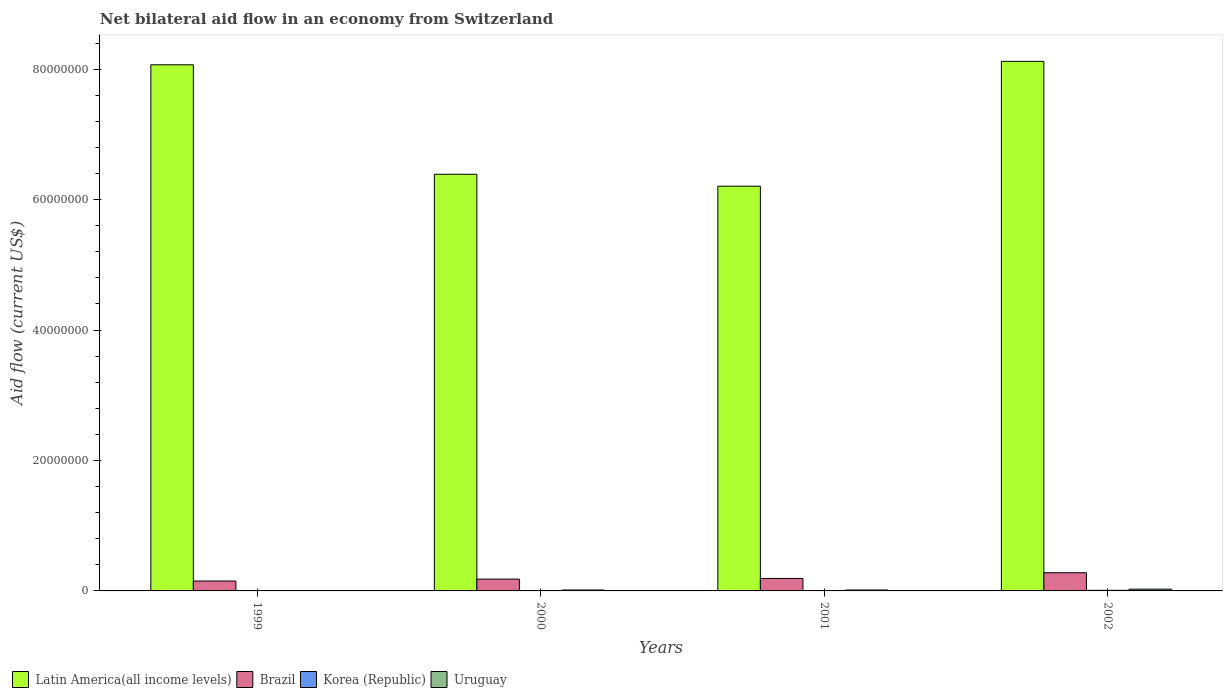How many groups of bars are there?
Make the answer very short. 4. Are the number of bars per tick equal to the number of legend labels?
Make the answer very short. Yes. How many bars are there on the 4th tick from the left?
Your answer should be very brief. 4. What is the label of the 2nd group of bars from the left?
Make the answer very short. 2000. In how many cases, is the number of bars for a given year not equal to the number of legend labels?
Your answer should be very brief. 0. What is the net bilateral aid flow in Latin America(all income levels) in 2000?
Make the answer very short. 6.39e+07. What is the total net bilateral aid flow in Uruguay in the graph?
Offer a terse response. 5.80e+05. What is the difference between the net bilateral aid flow in Korea (Republic) in 2000 and that in 2002?
Your response must be concise. -5.00e+04. What is the difference between the net bilateral aid flow in Latin America(all income levels) in 2002 and the net bilateral aid flow in Korea (Republic) in 1999?
Keep it short and to the point. 8.11e+07. What is the average net bilateral aid flow in Korea (Republic) per year?
Give a very brief answer. 6.00e+04. In the year 1999, what is the difference between the net bilateral aid flow in Korea (Republic) and net bilateral aid flow in Brazil?
Offer a very short reply. -1.47e+06. What is the ratio of the net bilateral aid flow in Latin America(all income levels) in 2000 to that in 2002?
Give a very brief answer. 0.79. What is the difference between the highest and the second highest net bilateral aid flow in Uruguay?
Provide a succinct answer. 1.30e+05. What is the difference between the highest and the lowest net bilateral aid flow in Latin America(all income levels)?
Your answer should be very brief. 1.91e+07. Is the sum of the net bilateral aid flow in Brazil in 2000 and 2002 greater than the maximum net bilateral aid flow in Latin America(all income levels) across all years?
Your answer should be compact. No. Is it the case that in every year, the sum of the net bilateral aid flow in Latin America(all income levels) and net bilateral aid flow in Brazil is greater than the sum of net bilateral aid flow in Uruguay and net bilateral aid flow in Korea (Republic)?
Give a very brief answer. Yes. What does the 1st bar from the left in 2001 represents?
Ensure brevity in your answer.  Latin America(all income levels). What does the 1st bar from the right in 2002 represents?
Your response must be concise. Uruguay. Are all the bars in the graph horizontal?
Offer a terse response. No. How are the legend labels stacked?
Ensure brevity in your answer.  Horizontal. What is the title of the graph?
Make the answer very short. Net bilateral aid flow in an economy from Switzerland. What is the label or title of the Y-axis?
Your response must be concise. Aid flow (current US$). What is the Aid flow (current US$) of Latin America(all income levels) in 1999?
Offer a very short reply. 8.07e+07. What is the Aid flow (current US$) of Brazil in 1999?
Your response must be concise. 1.52e+06. What is the Aid flow (current US$) of Uruguay in 1999?
Ensure brevity in your answer.  3.00e+04. What is the Aid flow (current US$) of Latin America(all income levels) in 2000?
Make the answer very short. 6.39e+07. What is the Aid flow (current US$) in Brazil in 2000?
Make the answer very short. 1.81e+06. What is the Aid flow (current US$) in Korea (Republic) in 2000?
Your answer should be very brief. 4.00e+04. What is the Aid flow (current US$) of Latin America(all income levels) in 2001?
Give a very brief answer. 6.20e+07. What is the Aid flow (current US$) in Brazil in 2001?
Offer a terse response. 1.91e+06. What is the Aid flow (current US$) of Latin America(all income levels) in 2002?
Make the answer very short. 8.12e+07. What is the Aid flow (current US$) in Brazil in 2002?
Your response must be concise. 2.79e+06. What is the Aid flow (current US$) in Uruguay in 2002?
Ensure brevity in your answer.  2.70e+05. Across all years, what is the maximum Aid flow (current US$) in Latin America(all income levels)?
Give a very brief answer. 8.12e+07. Across all years, what is the maximum Aid flow (current US$) in Brazil?
Your answer should be very brief. 2.79e+06. Across all years, what is the maximum Aid flow (current US$) of Korea (Republic)?
Your response must be concise. 9.00e+04. Across all years, what is the maximum Aid flow (current US$) in Uruguay?
Provide a short and direct response. 2.70e+05. Across all years, what is the minimum Aid flow (current US$) of Latin America(all income levels)?
Provide a succinct answer. 6.20e+07. Across all years, what is the minimum Aid flow (current US$) of Brazil?
Offer a terse response. 1.52e+06. Across all years, what is the minimum Aid flow (current US$) in Uruguay?
Your response must be concise. 3.00e+04. What is the total Aid flow (current US$) of Latin America(all income levels) in the graph?
Provide a short and direct response. 2.88e+08. What is the total Aid flow (current US$) in Brazil in the graph?
Your answer should be very brief. 8.03e+06. What is the total Aid flow (current US$) of Korea (Republic) in the graph?
Your answer should be compact. 2.40e+05. What is the total Aid flow (current US$) in Uruguay in the graph?
Your response must be concise. 5.80e+05. What is the difference between the Aid flow (current US$) of Latin America(all income levels) in 1999 and that in 2000?
Offer a terse response. 1.68e+07. What is the difference between the Aid flow (current US$) of Latin America(all income levels) in 1999 and that in 2001?
Keep it short and to the point. 1.86e+07. What is the difference between the Aid flow (current US$) in Brazil in 1999 and that in 2001?
Provide a succinct answer. -3.90e+05. What is the difference between the Aid flow (current US$) in Latin America(all income levels) in 1999 and that in 2002?
Provide a succinct answer. -5.30e+05. What is the difference between the Aid flow (current US$) in Brazil in 1999 and that in 2002?
Keep it short and to the point. -1.27e+06. What is the difference between the Aid flow (current US$) in Uruguay in 1999 and that in 2002?
Keep it short and to the point. -2.40e+05. What is the difference between the Aid flow (current US$) in Latin America(all income levels) in 2000 and that in 2001?
Your response must be concise. 1.83e+06. What is the difference between the Aid flow (current US$) of Uruguay in 2000 and that in 2001?
Your response must be concise. 0. What is the difference between the Aid flow (current US$) in Latin America(all income levels) in 2000 and that in 2002?
Provide a succinct answer. -1.73e+07. What is the difference between the Aid flow (current US$) in Brazil in 2000 and that in 2002?
Provide a short and direct response. -9.80e+05. What is the difference between the Aid flow (current US$) in Uruguay in 2000 and that in 2002?
Keep it short and to the point. -1.30e+05. What is the difference between the Aid flow (current US$) in Latin America(all income levels) in 2001 and that in 2002?
Make the answer very short. -1.91e+07. What is the difference between the Aid flow (current US$) in Brazil in 2001 and that in 2002?
Offer a terse response. -8.80e+05. What is the difference between the Aid flow (current US$) of Korea (Republic) in 2001 and that in 2002?
Provide a succinct answer. -3.00e+04. What is the difference between the Aid flow (current US$) of Uruguay in 2001 and that in 2002?
Offer a very short reply. -1.30e+05. What is the difference between the Aid flow (current US$) of Latin America(all income levels) in 1999 and the Aid flow (current US$) of Brazil in 2000?
Offer a terse response. 7.88e+07. What is the difference between the Aid flow (current US$) of Latin America(all income levels) in 1999 and the Aid flow (current US$) of Korea (Republic) in 2000?
Offer a terse response. 8.06e+07. What is the difference between the Aid flow (current US$) of Latin America(all income levels) in 1999 and the Aid flow (current US$) of Uruguay in 2000?
Make the answer very short. 8.05e+07. What is the difference between the Aid flow (current US$) of Brazil in 1999 and the Aid flow (current US$) of Korea (Republic) in 2000?
Give a very brief answer. 1.48e+06. What is the difference between the Aid flow (current US$) in Brazil in 1999 and the Aid flow (current US$) in Uruguay in 2000?
Your answer should be very brief. 1.38e+06. What is the difference between the Aid flow (current US$) of Latin America(all income levels) in 1999 and the Aid flow (current US$) of Brazil in 2001?
Offer a very short reply. 7.88e+07. What is the difference between the Aid flow (current US$) of Latin America(all income levels) in 1999 and the Aid flow (current US$) of Korea (Republic) in 2001?
Give a very brief answer. 8.06e+07. What is the difference between the Aid flow (current US$) of Latin America(all income levels) in 1999 and the Aid flow (current US$) of Uruguay in 2001?
Provide a succinct answer. 8.05e+07. What is the difference between the Aid flow (current US$) of Brazil in 1999 and the Aid flow (current US$) of Korea (Republic) in 2001?
Offer a terse response. 1.46e+06. What is the difference between the Aid flow (current US$) of Brazil in 1999 and the Aid flow (current US$) of Uruguay in 2001?
Offer a terse response. 1.38e+06. What is the difference between the Aid flow (current US$) of Latin America(all income levels) in 1999 and the Aid flow (current US$) of Brazil in 2002?
Keep it short and to the point. 7.79e+07. What is the difference between the Aid flow (current US$) in Latin America(all income levels) in 1999 and the Aid flow (current US$) in Korea (Republic) in 2002?
Provide a short and direct response. 8.06e+07. What is the difference between the Aid flow (current US$) of Latin America(all income levels) in 1999 and the Aid flow (current US$) of Uruguay in 2002?
Provide a short and direct response. 8.04e+07. What is the difference between the Aid flow (current US$) of Brazil in 1999 and the Aid flow (current US$) of Korea (Republic) in 2002?
Offer a very short reply. 1.43e+06. What is the difference between the Aid flow (current US$) in Brazil in 1999 and the Aid flow (current US$) in Uruguay in 2002?
Ensure brevity in your answer.  1.25e+06. What is the difference between the Aid flow (current US$) in Korea (Republic) in 1999 and the Aid flow (current US$) in Uruguay in 2002?
Make the answer very short. -2.20e+05. What is the difference between the Aid flow (current US$) in Latin America(all income levels) in 2000 and the Aid flow (current US$) in Brazil in 2001?
Ensure brevity in your answer.  6.20e+07. What is the difference between the Aid flow (current US$) in Latin America(all income levels) in 2000 and the Aid flow (current US$) in Korea (Republic) in 2001?
Provide a succinct answer. 6.38e+07. What is the difference between the Aid flow (current US$) in Latin America(all income levels) in 2000 and the Aid flow (current US$) in Uruguay in 2001?
Offer a terse response. 6.37e+07. What is the difference between the Aid flow (current US$) of Brazil in 2000 and the Aid flow (current US$) of Korea (Republic) in 2001?
Give a very brief answer. 1.75e+06. What is the difference between the Aid flow (current US$) of Brazil in 2000 and the Aid flow (current US$) of Uruguay in 2001?
Give a very brief answer. 1.67e+06. What is the difference between the Aid flow (current US$) of Korea (Republic) in 2000 and the Aid flow (current US$) of Uruguay in 2001?
Your response must be concise. -1.00e+05. What is the difference between the Aid flow (current US$) of Latin America(all income levels) in 2000 and the Aid flow (current US$) of Brazil in 2002?
Keep it short and to the point. 6.11e+07. What is the difference between the Aid flow (current US$) in Latin America(all income levels) in 2000 and the Aid flow (current US$) in Korea (Republic) in 2002?
Your answer should be compact. 6.38e+07. What is the difference between the Aid flow (current US$) of Latin America(all income levels) in 2000 and the Aid flow (current US$) of Uruguay in 2002?
Give a very brief answer. 6.36e+07. What is the difference between the Aid flow (current US$) in Brazil in 2000 and the Aid flow (current US$) in Korea (Republic) in 2002?
Offer a very short reply. 1.72e+06. What is the difference between the Aid flow (current US$) in Brazil in 2000 and the Aid flow (current US$) in Uruguay in 2002?
Provide a short and direct response. 1.54e+06. What is the difference between the Aid flow (current US$) in Korea (Republic) in 2000 and the Aid flow (current US$) in Uruguay in 2002?
Offer a very short reply. -2.30e+05. What is the difference between the Aid flow (current US$) in Latin America(all income levels) in 2001 and the Aid flow (current US$) in Brazil in 2002?
Ensure brevity in your answer.  5.93e+07. What is the difference between the Aid flow (current US$) in Latin America(all income levels) in 2001 and the Aid flow (current US$) in Korea (Republic) in 2002?
Make the answer very short. 6.20e+07. What is the difference between the Aid flow (current US$) in Latin America(all income levels) in 2001 and the Aid flow (current US$) in Uruguay in 2002?
Your response must be concise. 6.18e+07. What is the difference between the Aid flow (current US$) in Brazil in 2001 and the Aid flow (current US$) in Korea (Republic) in 2002?
Your response must be concise. 1.82e+06. What is the difference between the Aid flow (current US$) in Brazil in 2001 and the Aid flow (current US$) in Uruguay in 2002?
Your response must be concise. 1.64e+06. What is the difference between the Aid flow (current US$) in Korea (Republic) in 2001 and the Aid flow (current US$) in Uruguay in 2002?
Provide a short and direct response. -2.10e+05. What is the average Aid flow (current US$) in Latin America(all income levels) per year?
Make the answer very short. 7.19e+07. What is the average Aid flow (current US$) of Brazil per year?
Provide a succinct answer. 2.01e+06. What is the average Aid flow (current US$) in Uruguay per year?
Offer a very short reply. 1.45e+05. In the year 1999, what is the difference between the Aid flow (current US$) of Latin America(all income levels) and Aid flow (current US$) of Brazil?
Make the answer very short. 7.91e+07. In the year 1999, what is the difference between the Aid flow (current US$) in Latin America(all income levels) and Aid flow (current US$) in Korea (Republic)?
Your answer should be compact. 8.06e+07. In the year 1999, what is the difference between the Aid flow (current US$) of Latin America(all income levels) and Aid flow (current US$) of Uruguay?
Provide a succinct answer. 8.06e+07. In the year 1999, what is the difference between the Aid flow (current US$) in Brazil and Aid flow (current US$) in Korea (Republic)?
Your answer should be very brief. 1.47e+06. In the year 1999, what is the difference between the Aid flow (current US$) of Brazil and Aid flow (current US$) of Uruguay?
Give a very brief answer. 1.49e+06. In the year 2000, what is the difference between the Aid flow (current US$) in Latin America(all income levels) and Aid flow (current US$) in Brazil?
Your answer should be very brief. 6.21e+07. In the year 2000, what is the difference between the Aid flow (current US$) of Latin America(all income levels) and Aid flow (current US$) of Korea (Republic)?
Your answer should be very brief. 6.38e+07. In the year 2000, what is the difference between the Aid flow (current US$) of Latin America(all income levels) and Aid flow (current US$) of Uruguay?
Offer a very short reply. 6.37e+07. In the year 2000, what is the difference between the Aid flow (current US$) of Brazil and Aid flow (current US$) of Korea (Republic)?
Ensure brevity in your answer.  1.77e+06. In the year 2000, what is the difference between the Aid flow (current US$) in Brazil and Aid flow (current US$) in Uruguay?
Offer a very short reply. 1.67e+06. In the year 2001, what is the difference between the Aid flow (current US$) in Latin America(all income levels) and Aid flow (current US$) in Brazil?
Ensure brevity in your answer.  6.01e+07. In the year 2001, what is the difference between the Aid flow (current US$) in Latin America(all income levels) and Aid flow (current US$) in Korea (Republic)?
Offer a terse response. 6.20e+07. In the year 2001, what is the difference between the Aid flow (current US$) of Latin America(all income levels) and Aid flow (current US$) of Uruguay?
Ensure brevity in your answer.  6.19e+07. In the year 2001, what is the difference between the Aid flow (current US$) in Brazil and Aid flow (current US$) in Korea (Republic)?
Your answer should be compact. 1.85e+06. In the year 2001, what is the difference between the Aid flow (current US$) of Brazil and Aid flow (current US$) of Uruguay?
Give a very brief answer. 1.77e+06. In the year 2002, what is the difference between the Aid flow (current US$) in Latin America(all income levels) and Aid flow (current US$) in Brazil?
Your answer should be very brief. 7.84e+07. In the year 2002, what is the difference between the Aid flow (current US$) in Latin America(all income levels) and Aid flow (current US$) in Korea (Republic)?
Offer a very short reply. 8.11e+07. In the year 2002, what is the difference between the Aid flow (current US$) of Latin America(all income levels) and Aid flow (current US$) of Uruguay?
Make the answer very short. 8.09e+07. In the year 2002, what is the difference between the Aid flow (current US$) of Brazil and Aid flow (current US$) of Korea (Republic)?
Your answer should be very brief. 2.70e+06. In the year 2002, what is the difference between the Aid flow (current US$) of Brazil and Aid flow (current US$) of Uruguay?
Your answer should be compact. 2.52e+06. In the year 2002, what is the difference between the Aid flow (current US$) in Korea (Republic) and Aid flow (current US$) in Uruguay?
Your answer should be compact. -1.80e+05. What is the ratio of the Aid flow (current US$) in Latin America(all income levels) in 1999 to that in 2000?
Your answer should be very brief. 1.26. What is the ratio of the Aid flow (current US$) in Brazil in 1999 to that in 2000?
Make the answer very short. 0.84. What is the ratio of the Aid flow (current US$) of Korea (Republic) in 1999 to that in 2000?
Your answer should be very brief. 1.25. What is the ratio of the Aid flow (current US$) of Uruguay in 1999 to that in 2000?
Keep it short and to the point. 0.21. What is the ratio of the Aid flow (current US$) in Latin America(all income levels) in 1999 to that in 2001?
Your answer should be compact. 1.3. What is the ratio of the Aid flow (current US$) of Brazil in 1999 to that in 2001?
Provide a succinct answer. 0.8. What is the ratio of the Aid flow (current US$) in Korea (Republic) in 1999 to that in 2001?
Offer a terse response. 0.83. What is the ratio of the Aid flow (current US$) in Uruguay in 1999 to that in 2001?
Make the answer very short. 0.21. What is the ratio of the Aid flow (current US$) of Brazil in 1999 to that in 2002?
Offer a very short reply. 0.54. What is the ratio of the Aid flow (current US$) of Korea (Republic) in 1999 to that in 2002?
Make the answer very short. 0.56. What is the ratio of the Aid flow (current US$) in Latin America(all income levels) in 2000 to that in 2001?
Your answer should be compact. 1.03. What is the ratio of the Aid flow (current US$) of Brazil in 2000 to that in 2001?
Offer a terse response. 0.95. What is the ratio of the Aid flow (current US$) of Korea (Republic) in 2000 to that in 2001?
Provide a succinct answer. 0.67. What is the ratio of the Aid flow (current US$) of Latin America(all income levels) in 2000 to that in 2002?
Offer a terse response. 0.79. What is the ratio of the Aid flow (current US$) of Brazil in 2000 to that in 2002?
Make the answer very short. 0.65. What is the ratio of the Aid flow (current US$) of Korea (Republic) in 2000 to that in 2002?
Ensure brevity in your answer.  0.44. What is the ratio of the Aid flow (current US$) of Uruguay in 2000 to that in 2002?
Your answer should be very brief. 0.52. What is the ratio of the Aid flow (current US$) of Latin America(all income levels) in 2001 to that in 2002?
Provide a short and direct response. 0.76. What is the ratio of the Aid flow (current US$) of Brazil in 2001 to that in 2002?
Provide a short and direct response. 0.68. What is the ratio of the Aid flow (current US$) of Uruguay in 2001 to that in 2002?
Offer a terse response. 0.52. What is the difference between the highest and the second highest Aid flow (current US$) of Latin America(all income levels)?
Offer a very short reply. 5.30e+05. What is the difference between the highest and the second highest Aid flow (current US$) of Brazil?
Provide a succinct answer. 8.80e+05. What is the difference between the highest and the second highest Aid flow (current US$) of Uruguay?
Offer a terse response. 1.30e+05. What is the difference between the highest and the lowest Aid flow (current US$) of Latin America(all income levels)?
Your response must be concise. 1.91e+07. What is the difference between the highest and the lowest Aid flow (current US$) in Brazil?
Provide a short and direct response. 1.27e+06. 